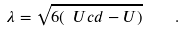Convert formula to latex. <formula><loc_0><loc_0><loc_500><loc_500>\lambda = \sqrt { 6 ( \ U c d - U ) } \quad .</formula> 